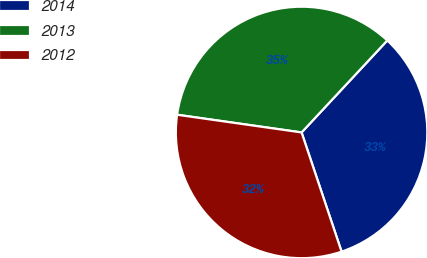<chart> <loc_0><loc_0><loc_500><loc_500><pie_chart><fcel>2014<fcel>2013<fcel>2012<nl><fcel>32.91%<fcel>34.69%<fcel>32.4%<nl></chart> 